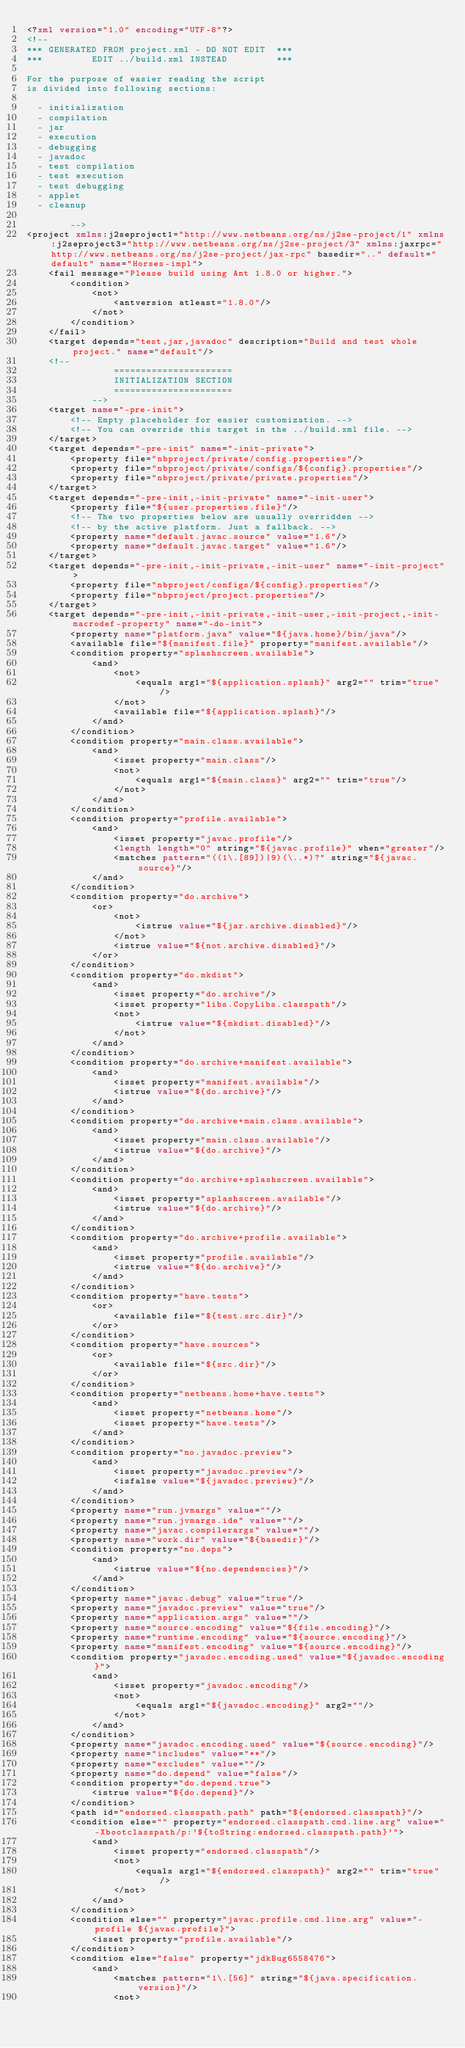<code> <loc_0><loc_0><loc_500><loc_500><_XML_><?xml version="1.0" encoding="UTF-8"?>
<!--
*** GENERATED FROM project.xml - DO NOT EDIT  ***
***         EDIT ../build.xml INSTEAD         ***

For the purpose of easier reading the script
is divided into following sections:

  - initialization
  - compilation
  - jar
  - execution
  - debugging
  - javadoc
  - test compilation
  - test execution
  - test debugging
  - applet
  - cleanup

        -->
<project xmlns:j2seproject1="http://www.netbeans.org/ns/j2se-project/1" xmlns:j2seproject3="http://www.netbeans.org/ns/j2se-project/3" xmlns:jaxrpc="http://www.netbeans.org/ns/j2se-project/jax-rpc" basedir=".." default="default" name="Horses-impl">
    <fail message="Please build using Ant 1.8.0 or higher.">
        <condition>
            <not>
                <antversion atleast="1.8.0"/>
            </not>
        </condition>
    </fail>
    <target depends="test,jar,javadoc" description="Build and test whole project." name="default"/>
    <!-- 
                ======================
                INITIALIZATION SECTION 
                ======================
            -->
    <target name="-pre-init">
        <!-- Empty placeholder for easier customization. -->
        <!-- You can override this target in the ../build.xml file. -->
    </target>
    <target depends="-pre-init" name="-init-private">
        <property file="nbproject/private/config.properties"/>
        <property file="nbproject/private/configs/${config}.properties"/>
        <property file="nbproject/private/private.properties"/>
    </target>
    <target depends="-pre-init,-init-private" name="-init-user">
        <property file="${user.properties.file}"/>
        <!-- The two properties below are usually overridden -->
        <!-- by the active platform. Just a fallback. -->
        <property name="default.javac.source" value="1.6"/>
        <property name="default.javac.target" value="1.6"/>
    </target>
    <target depends="-pre-init,-init-private,-init-user" name="-init-project">
        <property file="nbproject/configs/${config}.properties"/>
        <property file="nbproject/project.properties"/>
    </target>
    <target depends="-pre-init,-init-private,-init-user,-init-project,-init-macrodef-property" name="-do-init">
        <property name="platform.java" value="${java.home}/bin/java"/>
        <available file="${manifest.file}" property="manifest.available"/>
        <condition property="splashscreen.available">
            <and>
                <not>
                    <equals arg1="${application.splash}" arg2="" trim="true"/>
                </not>
                <available file="${application.splash}"/>
            </and>
        </condition>
        <condition property="main.class.available">
            <and>
                <isset property="main.class"/>
                <not>
                    <equals arg1="${main.class}" arg2="" trim="true"/>
                </not>
            </and>
        </condition>
        <condition property="profile.available">
            <and>
                <isset property="javac.profile"/>
                <length length="0" string="${javac.profile}" when="greater"/>
                <matches pattern="((1\.[89])|9)(\..*)?" string="${javac.source}"/>
            </and>
        </condition>
        <condition property="do.archive">
            <or>
                <not>
                    <istrue value="${jar.archive.disabled}"/>
                </not>
                <istrue value="${not.archive.disabled}"/>
            </or>
        </condition>
        <condition property="do.mkdist">
            <and>
                <isset property="do.archive"/>
                <isset property="libs.CopyLibs.classpath"/>
                <not>
                    <istrue value="${mkdist.disabled}"/>
                </not>
            </and>
        </condition>
        <condition property="do.archive+manifest.available">
            <and>
                <isset property="manifest.available"/>
                <istrue value="${do.archive}"/>
            </and>
        </condition>
        <condition property="do.archive+main.class.available">
            <and>
                <isset property="main.class.available"/>
                <istrue value="${do.archive}"/>
            </and>
        </condition>
        <condition property="do.archive+splashscreen.available">
            <and>
                <isset property="splashscreen.available"/>
                <istrue value="${do.archive}"/>
            </and>
        </condition>
        <condition property="do.archive+profile.available">
            <and>
                <isset property="profile.available"/>
                <istrue value="${do.archive}"/>
            </and>
        </condition>
        <condition property="have.tests">
            <or>
                <available file="${test.src.dir}"/>
            </or>
        </condition>
        <condition property="have.sources">
            <or>
                <available file="${src.dir}"/>
            </or>
        </condition>
        <condition property="netbeans.home+have.tests">
            <and>
                <isset property="netbeans.home"/>
                <isset property="have.tests"/>
            </and>
        </condition>
        <condition property="no.javadoc.preview">
            <and>
                <isset property="javadoc.preview"/>
                <isfalse value="${javadoc.preview}"/>
            </and>
        </condition>
        <property name="run.jvmargs" value=""/>
        <property name="run.jvmargs.ide" value=""/>
        <property name="javac.compilerargs" value=""/>
        <property name="work.dir" value="${basedir}"/>
        <condition property="no.deps">
            <and>
                <istrue value="${no.dependencies}"/>
            </and>
        </condition>
        <property name="javac.debug" value="true"/>
        <property name="javadoc.preview" value="true"/>
        <property name="application.args" value=""/>
        <property name="source.encoding" value="${file.encoding}"/>
        <property name="runtime.encoding" value="${source.encoding}"/>
        <property name="manifest.encoding" value="${source.encoding}"/>
        <condition property="javadoc.encoding.used" value="${javadoc.encoding}">
            <and>
                <isset property="javadoc.encoding"/>
                <not>
                    <equals arg1="${javadoc.encoding}" arg2=""/>
                </not>
            </and>
        </condition>
        <property name="javadoc.encoding.used" value="${source.encoding}"/>
        <property name="includes" value="**"/>
        <property name="excludes" value=""/>
        <property name="do.depend" value="false"/>
        <condition property="do.depend.true">
            <istrue value="${do.depend}"/>
        </condition>
        <path id="endorsed.classpath.path" path="${endorsed.classpath}"/>
        <condition else="" property="endorsed.classpath.cmd.line.arg" value="-Xbootclasspath/p:'${toString:endorsed.classpath.path}'">
            <and>
                <isset property="endorsed.classpath"/>
                <not>
                    <equals arg1="${endorsed.classpath}" arg2="" trim="true"/>
                </not>
            </and>
        </condition>
        <condition else="" property="javac.profile.cmd.line.arg" value="-profile ${javac.profile}">
            <isset property="profile.available"/>
        </condition>
        <condition else="false" property="jdkBug6558476">
            <and>
                <matches pattern="1\.[56]" string="${java.specification.version}"/>
                <not></code> 